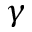Convert formula to latex. <formula><loc_0><loc_0><loc_500><loc_500>\gamma</formula> 